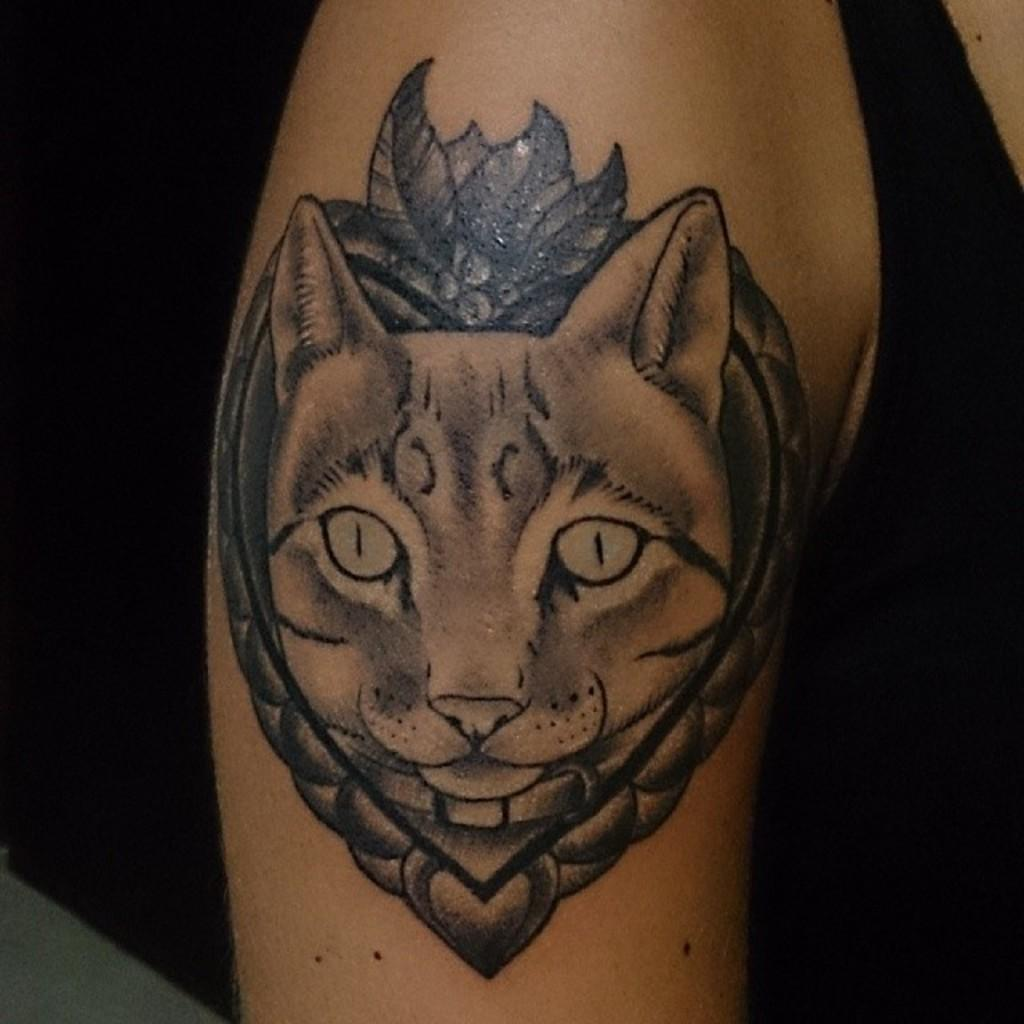What is present on the hand in the image? There is a tattoo on a hand in the image. What is depicted in the tattoo? The tattoo contains an animal face. What type of metal can be seen attached to the animal face in the tattoo? There is no metal present in the tattoo; it only contains an animal face. What type of nut is visible in the tattoo? There is no nut present in the tattoo; it only contains an animal face. 